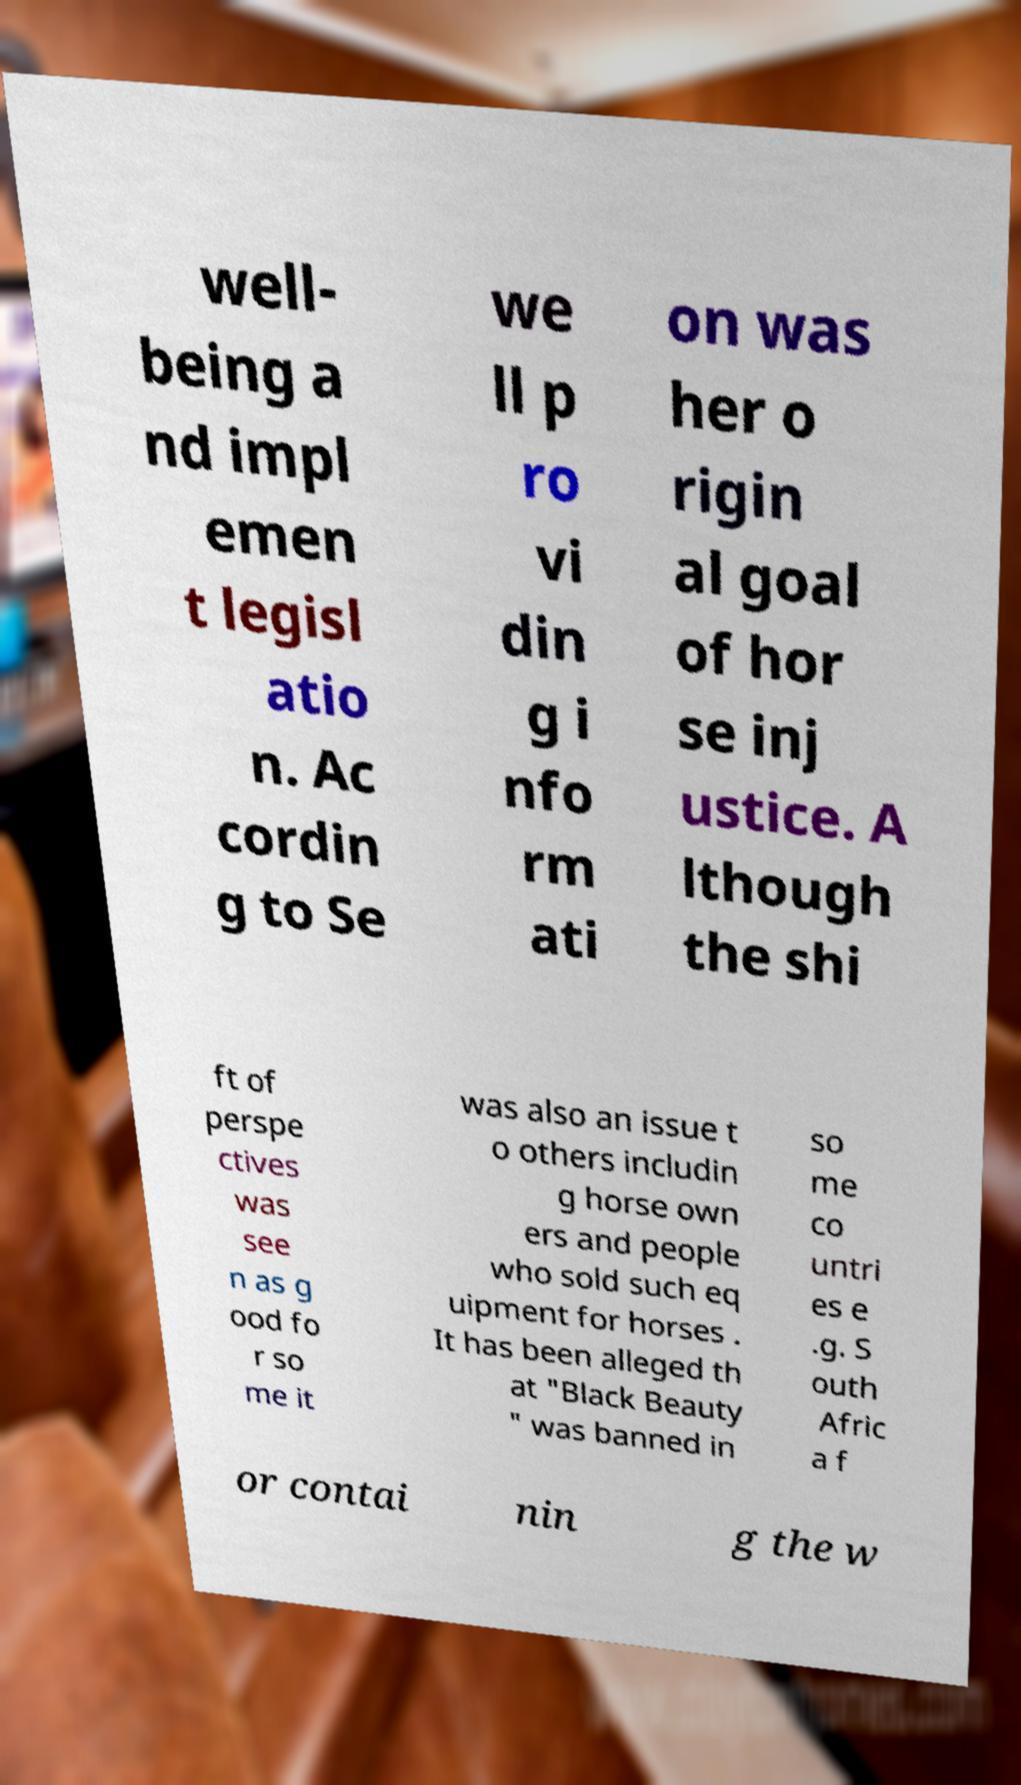There's text embedded in this image that I need extracted. Can you transcribe it verbatim? well- being a nd impl emen t legisl atio n. Ac cordin g to Se we ll p ro vi din g i nfo rm ati on was her o rigin al goal of hor se inj ustice. A lthough the shi ft of perspe ctives was see n as g ood fo r so me it was also an issue t o others includin g horse own ers and people who sold such eq uipment for horses . It has been alleged th at "Black Beauty " was banned in so me co untri es e .g. S outh Afric a f or contai nin g the w 